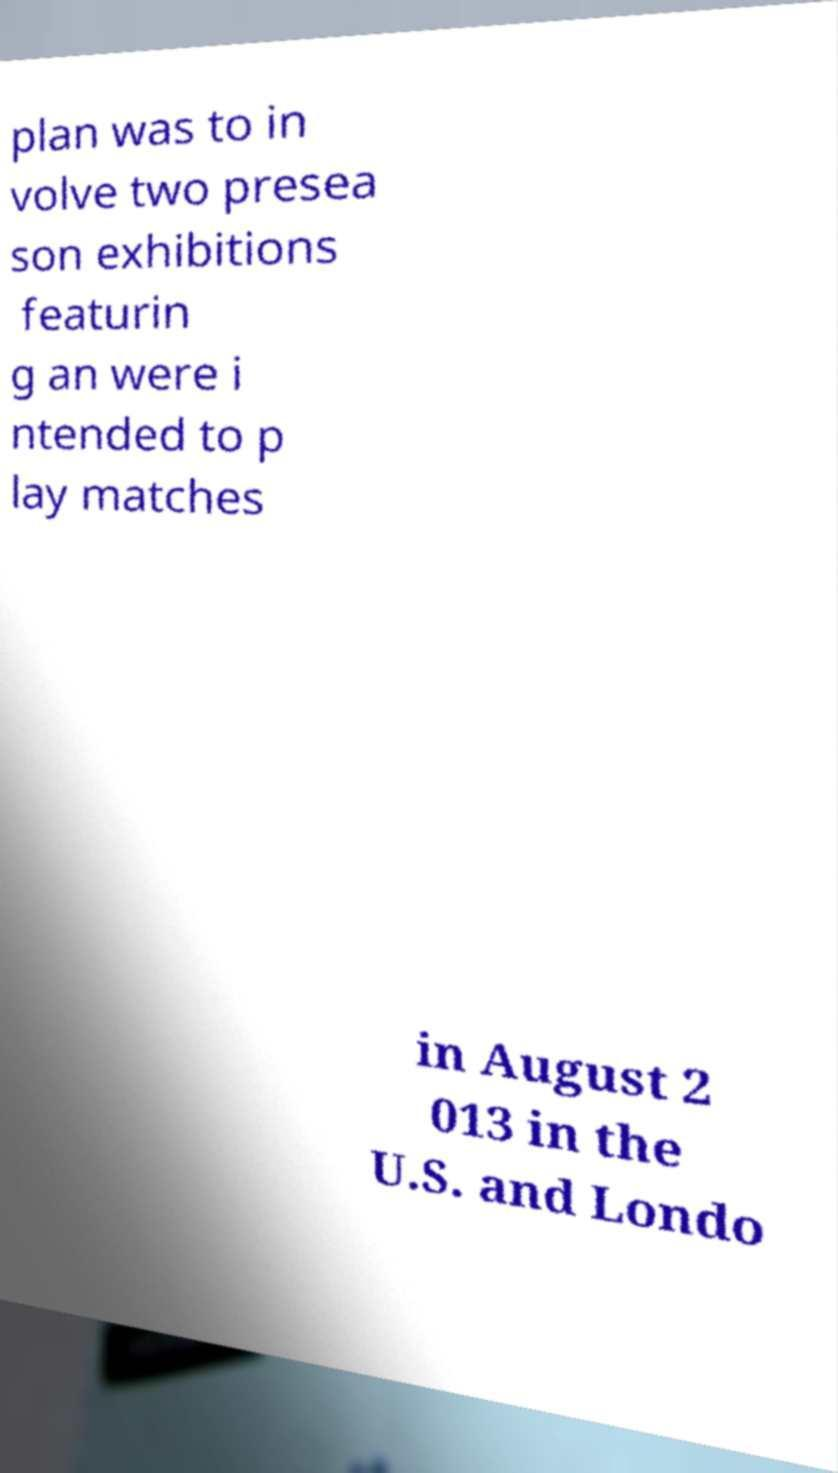Could you assist in decoding the text presented in this image and type it out clearly? plan was to in volve two presea son exhibitions featurin g an were i ntended to p lay matches in August 2 013 in the U.S. and Londo 